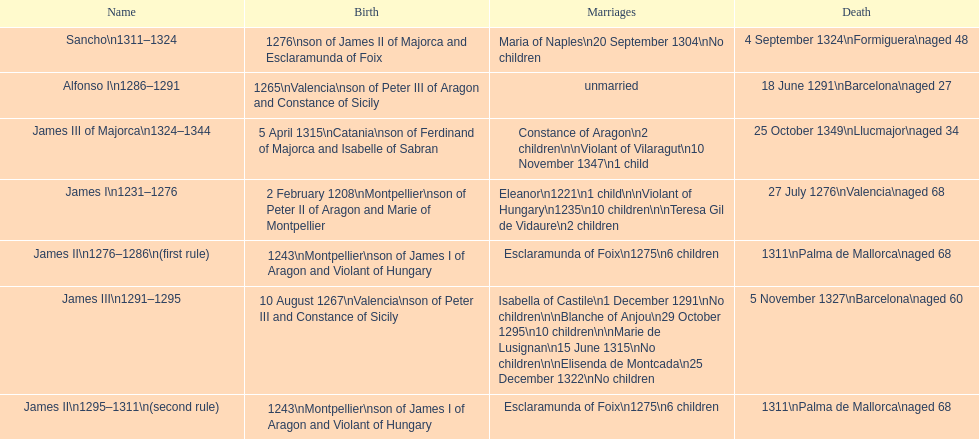What name is above james iii and below james ii? Alfonso I. 